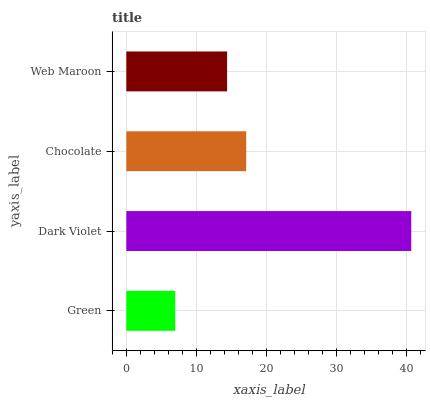Is Green the minimum?
Answer yes or no. Yes. Is Dark Violet the maximum?
Answer yes or no. Yes. Is Chocolate the minimum?
Answer yes or no. No. Is Chocolate the maximum?
Answer yes or no. No. Is Dark Violet greater than Chocolate?
Answer yes or no. Yes. Is Chocolate less than Dark Violet?
Answer yes or no. Yes. Is Chocolate greater than Dark Violet?
Answer yes or no. No. Is Dark Violet less than Chocolate?
Answer yes or no. No. Is Chocolate the high median?
Answer yes or no. Yes. Is Web Maroon the low median?
Answer yes or no. Yes. Is Web Maroon the high median?
Answer yes or no. No. Is Chocolate the low median?
Answer yes or no. No. 